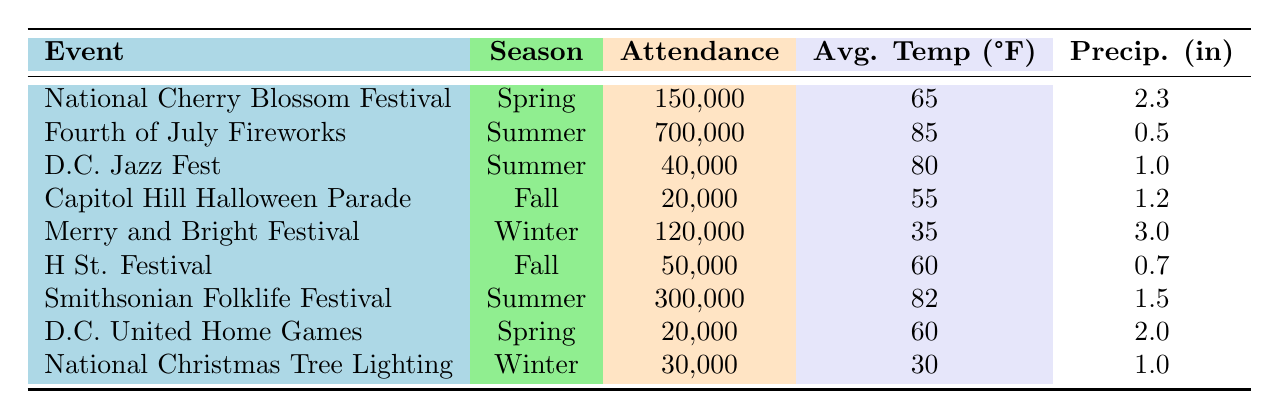What is the attendance for the National Cherry Blossom Festival? The table lists the National Cherry Blossom Festival under the event column, and next to it in the attendance column, it shows 150,000.
Answer: 150,000 Which season has the highest event attendance? Looking at the attendance values for each season, the Fourth of July Fireworks in Summer has 700,000, which is more than any other event listed.
Answer: Summer What is the average temperature during the Merry and Bright Festival? The table indicates the average temperature for the Merry and Bright Festival, listed under the avg_temp column, is 35°F.
Answer: 35°F What is the total attendance for events in Fall? The table shows two events in Fall with attendance figures of 20,000 (Capitol Hill Halloween Parade) and 50,000 (H St. Festival). Summing these gives 20,000 + 50,000 = 70,000.
Answer: 70,000 Which event had the lowest attendance? Comparing all attendance figures, the D.C. Jazz Fest has the lowest at 40,000.
Answer: 40,000 Is the average temperature for the Winter events higher than 32°F? The average temperatures for Winter events are 35°F (Merry and Bright Festival) and 30°F (National Christmas Tree Lighting). Since 35°F > 32°F, the answer is yes.
Answer: Yes What is the difference in attendance between the Fourth of July Fireworks and the Smithsonian Folklife Festival? The Fourth of July Fireworks had an attendance of 700,000, while the Smithsonian Folklife Festival had 300,000. The difference is 700,000 - 300,000 = 400,000.
Answer: 400,000 Which season had the highest average temperature? The highest average temperature is found in the Summer season, with the Fourth of July Fireworks having 85°F. This is higher than any event in other seasons.
Answer: Summer How many events had attendance figures greater than 100,000? The events with attendance greater than 100,000 are the Fourth of July Fireworks (700,000) and the National Cherry Blossom Festival (150,000), totaling 2 events.
Answer: 2 Was there any event in Winter with an attendance below 40,000? The National Christmas Tree Lighting in Winter had an attendance of 30,000, which is below 40,000. Therefore, the answer is yes.
Answer: Yes 